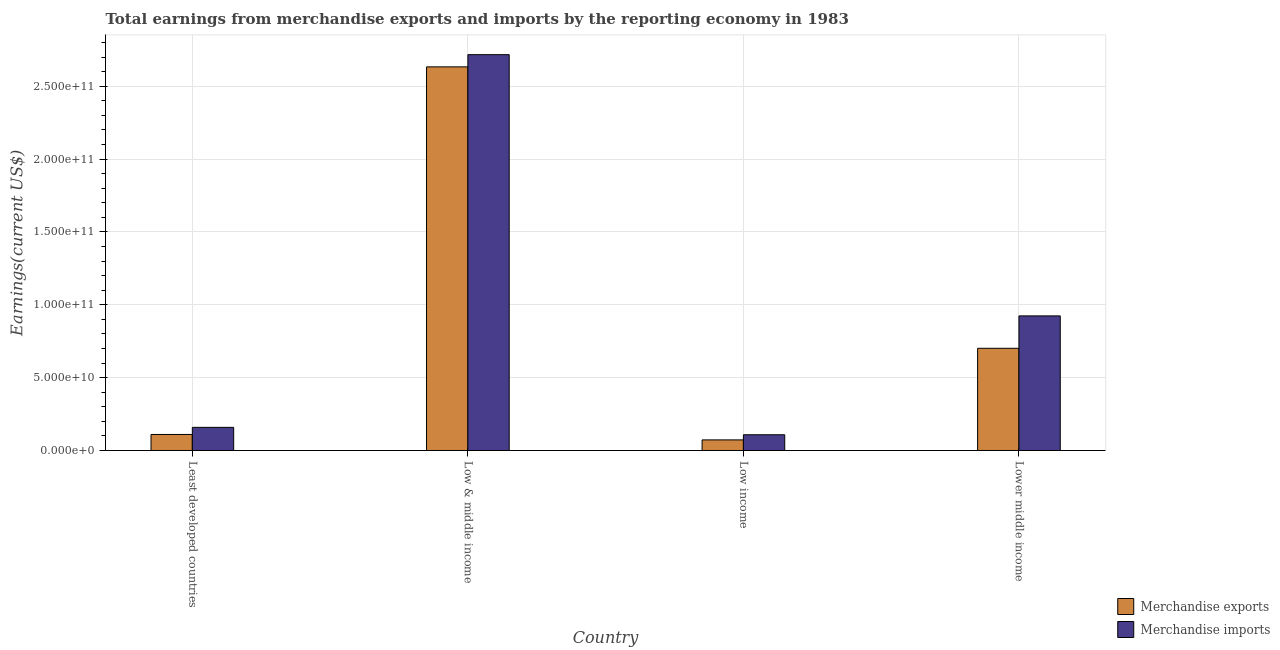Are the number of bars per tick equal to the number of legend labels?
Give a very brief answer. Yes. Are the number of bars on each tick of the X-axis equal?
Offer a very short reply. Yes. What is the label of the 4th group of bars from the left?
Your answer should be compact. Lower middle income. In how many cases, is the number of bars for a given country not equal to the number of legend labels?
Provide a succinct answer. 0. What is the earnings from merchandise imports in Low & middle income?
Give a very brief answer. 2.72e+11. Across all countries, what is the maximum earnings from merchandise exports?
Your response must be concise. 2.63e+11. Across all countries, what is the minimum earnings from merchandise imports?
Keep it short and to the point. 1.08e+1. In which country was the earnings from merchandise exports minimum?
Your answer should be very brief. Low income. What is the total earnings from merchandise imports in the graph?
Your answer should be compact. 3.91e+11. What is the difference between the earnings from merchandise exports in Least developed countries and that in Lower middle income?
Offer a very short reply. -5.91e+1. What is the difference between the earnings from merchandise exports in Low income and the earnings from merchandise imports in Least developed countries?
Give a very brief answer. -8.62e+09. What is the average earnings from merchandise exports per country?
Your response must be concise. 8.79e+1. What is the difference between the earnings from merchandise exports and earnings from merchandise imports in Lower middle income?
Provide a short and direct response. -2.22e+1. In how many countries, is the earnings from merchandise exports greater than 260000000000 US$?
Ensure brevity in your answer.  1. What is the ratio of the earnings from merchandise exports in Low & middle income to that in Lower middle income?
Provide a short and direct response. 3.75. Is the earnings from merchandise imports in Least developed countries less than that in Lower middle income?
Ensure brevity in your answer.  Yes. What is the difference between the highest and the second highest earnings from merchandise imports?
Your answer should be compact. 1.79e+11. What is the difference between the highest and the lowest earnings from merchandise exports?
Keep it short and to the point. 2.56e+11. What does the 2nd bar from the left in Lower middle income represents?
Keep it short and to the point. Merchandise imports. How many countries are there in the graph?
Offer a terse response. 4. What is the difference between two consecutive major ticks on the Y-axis?
Keep it short and to the point. 5.00e+1. Does the graph contain any zero values?
Provide a succinct answer. No. Where does the legend appear in the graph?
Provide a short and direct response. Bottom right. How many legend labels are there?
Make the answer very short. 2. How are the legend labels stacked?
Keep it short and to the point. Vertical. What is the title of the graph?
Give a very brief answer. Total earnings from merchandise exports and imports by the reporting economy in 1983. Does "Food and tobacco" appear as one of the legend labels in the graph?
Keep it short and to the point. No. What is the label or title of the X-axis?
Your answer should be very brief. Country. What is the label or title of the Y-axis?
Provide a succinct answer. Earnings(current US$). What is the Earnings(current US$) in Merchandise exports in Least developed countries?
Your answer should be compact. 1.10e+1. What is the Earnings(current US$) in Merchandise imports in Least developed countries?
Offer a terse response. 1.59e+1. What is the Earnings(current US$) of Merchandise exports in Low & middle income?
Give a very brief answer. 2.63e+11. What is the Earnings(current US$) in Merchandise imports in Low & middle income?
Your response must be concise. 2.72e+11. What is the Earnings(current US$) in Merchandise exports in Low income?
Make the answer very short. 7.26e+09. What is the Earnings(current US$) of Merchandise imports in Low income?
Your answer should be compact. 1.08e+1. What is the Earnings(current US$) of Merchandise exports in Lower middle income?
Offer a terse response. 7.01e+1. What is the Earnings(current US$) of Merchandise imports in Lower middle income?
Ensure brevity in your answer.  9.24e+1. Across all countries, what is the maximum Earnings(current US$) of Merchandise exports?
Make the answer very short. 2.63e+11. Across all countries, what is the maximum Earnings(current US$) of Merchandise imports?
Your answer should be compact. 2.72e+11. Across all countries, what is the minimum Earnings(current US$) in Merchandise exports?
Provide a succinct answer. 7.26e+09. Across all countries, what is the minimum Earnings(current US$) in Merchandise imports?
Your answer should be very brief. 1.08e+1. What is the total Earnings(current US$) in Merchandise exports in the graph?
Give a very brief answer. 3.52e+11. What is the total Earnings(current US$) in Merchandise imports in the graph?
Provide a succinct answer. 3.91e+11. What is the difference between the Earnings(current US$) of Merchandise exports in Least developed countries and that in Low & middle income?
Your answer should be compact. -2.52e+11. What is the difference between the Earnings(current US$) of Merchandise imports in Least developed countries and that in Low & middle income?
Provide a succinct answer. -2.56e+11. What is the difference between the Earnings(current US$) of Merchandise exports in Least developed countries and that in Low income?
Your answer should be very brief. 3.73e+09. What is the difference between the Earnings(current US$) of Merchandise imports in Least developed countries and that in Low income?
Make the answer very short. 5.09e+09. What is the difference between the Earnings(current US$) in Merchandise exports in Least developed countries and that in Lower middle income?
Your answer should be very brief. -5.91e+1. What is the difference between the Earnings(current US$) of Merchandise imports in Least developed countries and that in Lower middle income?
Provide a short and direct response. -7.65e+1. What is the difference between the Earnings(current US$) of Merchandise exports in Low & middle income and that in Low income?
Your answer should be compact. 2.56e+11. What is the difference between the Earnings(current US$) in Merchandise imports in Low & middle income and that in Low income?
Offer a very short reply. 2.61e+11. What is the difference between the Earnings(current US$) of Merchandise exports in Low & middle income and that in Lower middle income?
Your response must be concise. 1.93e+11. What is the difference between the Earnings(current US$) of Merchandise imports in Low & middle income and that in Lower middle income?
Your answer should be compact. 1.79e+11. What is the difference between the Earnings(current US$) in Merchandise exports in Low income and that in Lower middle income?
Provide a succinct answer. -6.29e+1. What is the difference between the Earnings(current US$) of Merchandise imports in Low income and that in Lower middle income?
Ensure brevity in your answer.  -8.16e+1. What is the difference between the Earnings(current US$) in Merchandise exports in Least developed countries and the Earnings(current US$) in Merchandise imports in Low & middle income?
Ensure brevity in your answer.  -2.61e+11. What is the difference between the Earnings(current US$) in Merchandise exports in Least developed countries and the Earnings(current US$) in Merchandise imports in Low income?
Offer a terse response. 2.07e+08. What is the difference between the Earnings(current US$) of Merchandise exports in Least developed countries and the Earnings(current US$) of Merchandise imports in Lower middle income?
Provide a short and direct response. -8.14e+1. What is the difference between the Earnings(current US$) in Merchandise exports in Low & middle income and the Earnings(current US$) in Merchandise imports in Low income?
Provide a succinct answer. 2.52e+11. What is the difference between the Earnings(current US$) in Merchandise exports in Low & middle income and the Earnings(current US$) in Merchandise imports in Lower middle income?
Your response must be concise. 1.71e+11. What is the difference between the Earnings(current US$) of Merchandise exports in Low income and the Earnings(current US$) of Merchandise imports in Lower middle income?
Offer a terse response. -8.51e+1. What is the average Earnings(current US$) of Merchandise exports per country?
Your response must be concise. 8.79e+1. What is the average Earnings(current US$) of Merchandise imports per country?
Offer a terse response. 9.77e+1. What is the difference between the Earnings(current US$) of Merchandise exports and Earnings(current US$) of Merchandise imports in Least developed countries?
Your answer should be very brief. -4.89e+09. What is the difference between the Earnings(current US$) in Merchandise exports and Earnings(current US$) in Merchandise imports in Low & middle income?
Your answer should be compact. -8.38e+09. What is the difference between the Earnings(current US$) of Merchandise exports and Earnings(current US$) of Merchandise imports in Low income?
Your answer should be very brief. -3.53e+09. What is the difference between the Earnings(current US$) in Merchandise exports and Earnings(current US$) in Merchandise imports in Lower middle income?
Provide a short and direct response. -2.22e+1. What is the ratio of the Earnings(current US$) in Merchandise exports in Least developed countries to that in Low & middle income?
Give a very brief answer. 0.04. What is the ratio of the Earnings(current US$) of Merchandise imports in Least developed countries to that in Low & middle income?
Your answer should be very brief. 0.06. What is the ratio of the Earnings(current US$) in Merchandise exports in Least developed countries to that in Low income?
Keep it short and to the point. 1.51. What is the ratio of the Earnings(current US$) in Merchandise imports in Least developed countries to that in Low income?
Provide a short and direct response. 1.47. What is the ratio of the Earnings(current US$) in Merchandise exports in Least developed countries to that in Lower middle income?
Your answer should be compact. 0.16. What is the ratio of the Earnings(current US$) in Merchandise imports in Least developed countries to that in Lower middle income?
Offer a very short reply. 0.17. What is the ratio of the Earnings(current US$) in Merchandise exports in Low & middle income to that in Low income?
Your answer should be very brief. 36.26. What is the ratio of the Earnings(current US$) in Merchandise imports in Low & middle income to that in Low income?
Provide a short and direct response. 25.18. What is the ratio of the Earnings(current US$) in Merchandise exports in Low & middle income to that in Lower middle income?
Your answer should be very brief. 3.75. What is the ratio of the Earnings(current US$) of Merchandise imports in Low & middle income to that in Lower middle income?
Provide a short and direct response. 2.94. What is the ratio of the Earnings(current US$) in Merchandise exports in Low income to that in Lower middle income?
Your response must be concise. 0.1. What is the ratio of the Earnings(current US$) of Merchandise imports in Low income to that in Lower middle income?
Keep it short and to the point. 0.12. What is the difference between the highest and the second highest Earnings(current US$) in Merchandise exports?
Ensure brevity in your answer.  1.93e+11. What is the difference between the highest and the second highest Earnings(current US$) in Merchandise imports?
Your answer should be very brief. 1.79e+11. What is the difference between the highest and the lowest Earnings(current US$) of Merchandise exports?
Your answer should be compact. 2.56e+11. What is the difference between the highest and the lowest Earnings(current US$) of Merchandise imports?
Offer a very short reply. 2.61e+11. 